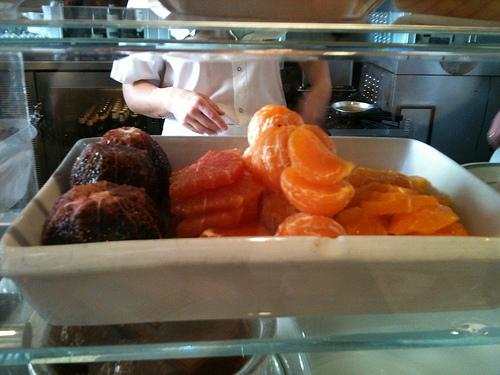Question: what is the orange fruit in the photo?
Choices:
A. Tangerine.
B. Mango.
C. Peaches.
D. Oranges.
Answer with the letter. Answer: D Question: what is the pink fruit in the photo?
Choices:
A. Kiwi.
B. Grapefruit.
C. Lemon.
D. Cherry.
Answer with the letter. Answer: B Question: what is the brown food next to the grapefruit?
Choices:
A. Cookie.
B. Cake.
C. Gravy.
D. Icecream.
Answer with the letter. Answer: B Question: what kind of cake is next to the grapefruit?
Choices:
A. Vanilla.
B. Chocolate.
C. Pound.
D. Red Velvet.
Answer with the letter. Answer: B 